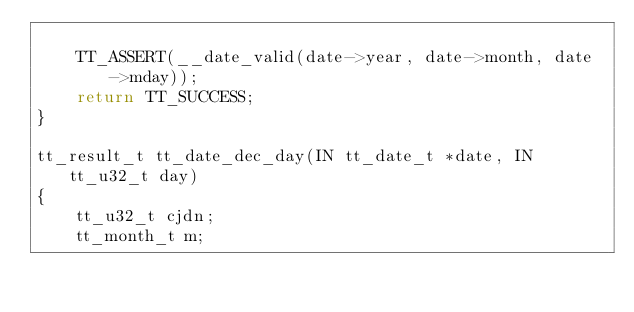<code> <loc_0><loc_0><loc_500><loc_500><_C_>
    TT_ASSERT(__date_valid(date->year, date->month, date->mday));
    return TT_SUCCESS;
}

tt_result_t tt_date_dec_day(IN tt_date_t *date, IN tt_u32_t day)
{
    tt_u32_t cjdn;
    tt_month_t m;
</code> 